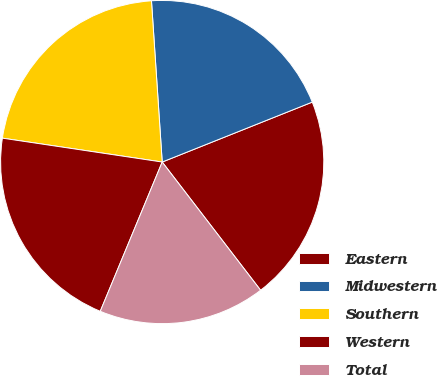Convert chart. <chart><loc_0><loc_0><loc_500><loc_500><pie_chart><fcel>Eastern<fcel>Midwestern<fcel>Southern<fcel>Western<fcel>Total<nl><fcel>20.63%<fcel>20.01%<fcel>21.58%<fcel>21.1%<fcel>16.68%<nl></chart> 